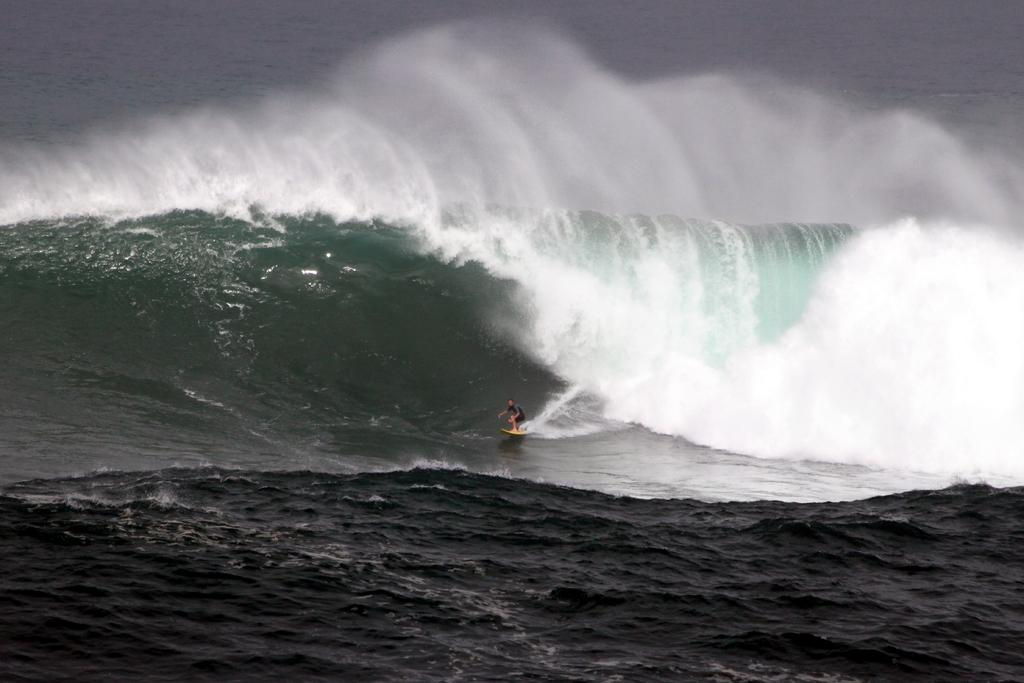What is the main subject of the image? There is a person in the image. What is the person doing in the image? The person is on a surfboard. What can be seen in the water in the image? Waves are visible in the water. What type of string is being used by the person to balance on the waves? There is no string visible in the image, and the person is not using any string to balance on the waves. 